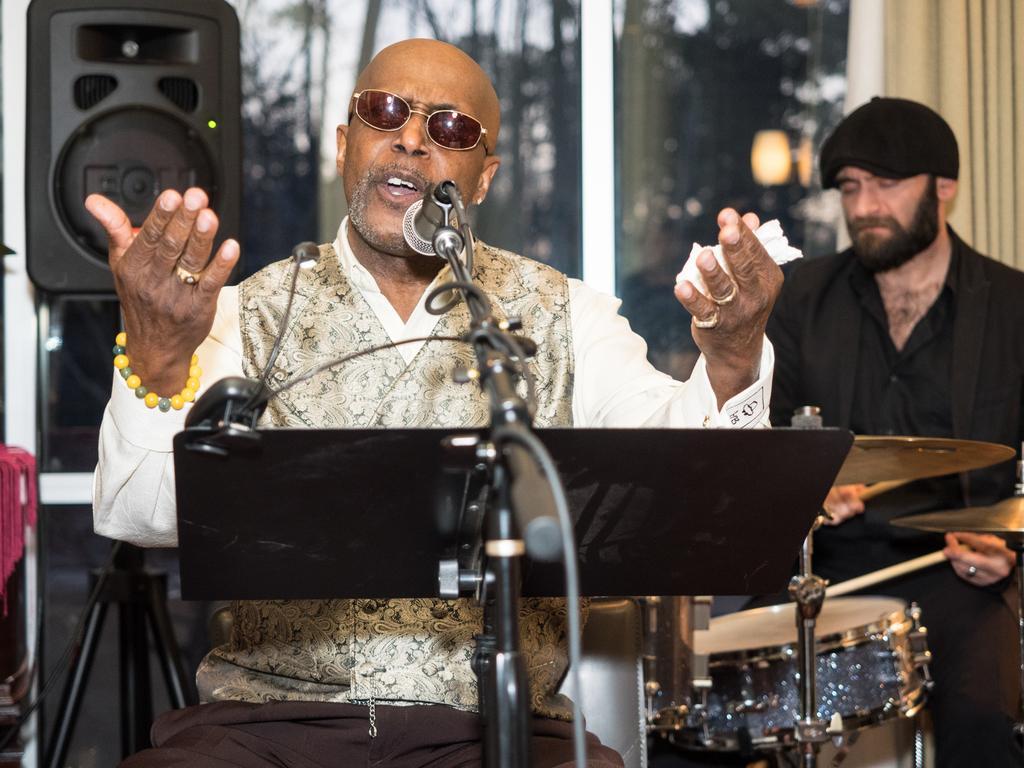Please provide a concise description of this image. This 2 persons are sitting. This person is singing in-front of mic, this person is playing a musical instrument. This is a board. A sound box with stand. A window with curtain. Far there are trees. 